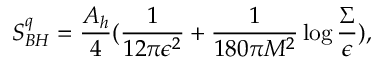<formula> <loc_0><loc_0><loc_500><loc_500>S _ { B H } ^ { q } = { \frac { A _ { h } } { 4 } } ( { \frac { 1 } { 1 2 \pi \epsilon ^ { 2 } } } + { \frac { 1 } { 1 8 0 \pi M ^ { 2 } } } \log { \frac { \Sigma } { \epsilon } } ) ,</formula> 